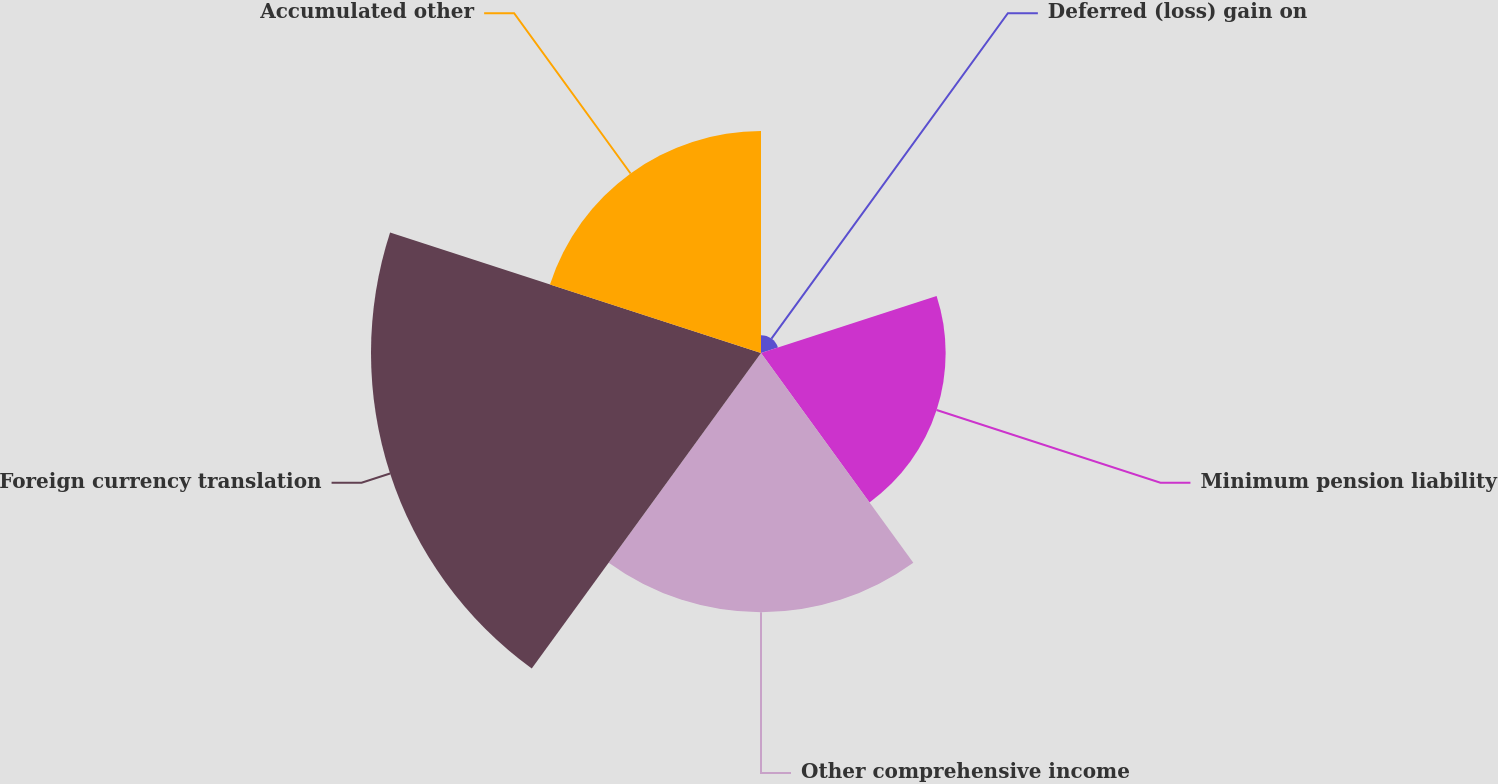Convert chart to OTSL. <chart><loc_0><loc_0><loc_500><loc_500><pie_chart><fcel>Deferred (loss) gain on<fcel>Minimum pension liability<fcel>Other comprehensive income<fcel>Foreign currency translation<fcel>Accumulated other<nl><fcel>1.66%<fcel>17.2%<fcel>24.14%<fcel>36.33%<fcel>20.67%<nl></chart> 